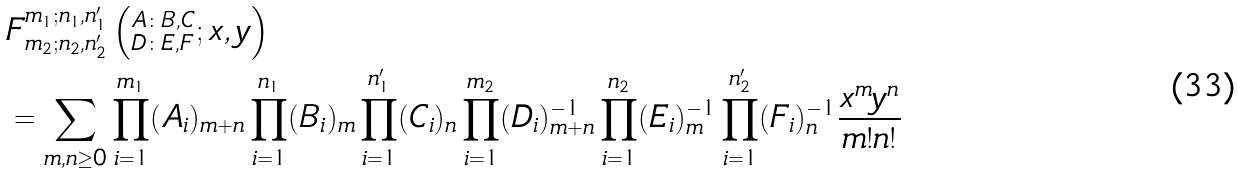Convert formula to latex. <formula><loc_0><loc_0><loc_500><loc_500>& F ^ { m _ { 1 } ; n _ { 1 } , n ^ { \prime } _ { 1 } } _ { m _ { 2 } ; n _ { 2 } , n ^ { \prime } _ { 2 } } \left ( ^ { A \colon B , C } _ { D \colon E , F } ; x , y \right ) \\ & = \sum _ { m , n \geq 0 } \prod _ { i = 1 } ^ { m _ { 1 } } ( A _ { i } ) _ { m + n } \prod _ { i = 1 } ^ { n _ { 1 } } ( B _ { i } ) _ { m } \prod _ { i = 1 } ^ { n ^ { \prime } _ { 1 } } ( C _ { i } ) _ { n } \prod _ { i = 1 } ^ { m _ { 2 } } ( D _ { i } ) ^ { - 1 } _ { m + n } \prod _ { i = 1 } ^ { n _ { 2 } } ( E _ { i } ) ^ { - 1 } _ { m } \prod _ { i = 1 } ^ { n ^ { \prime } _ { 2 } } ( F _ { i } ) ^ { - 1 } _ { n } \frac { x ^ { m } y ^ { n } } { m ! n ! }</formula> 